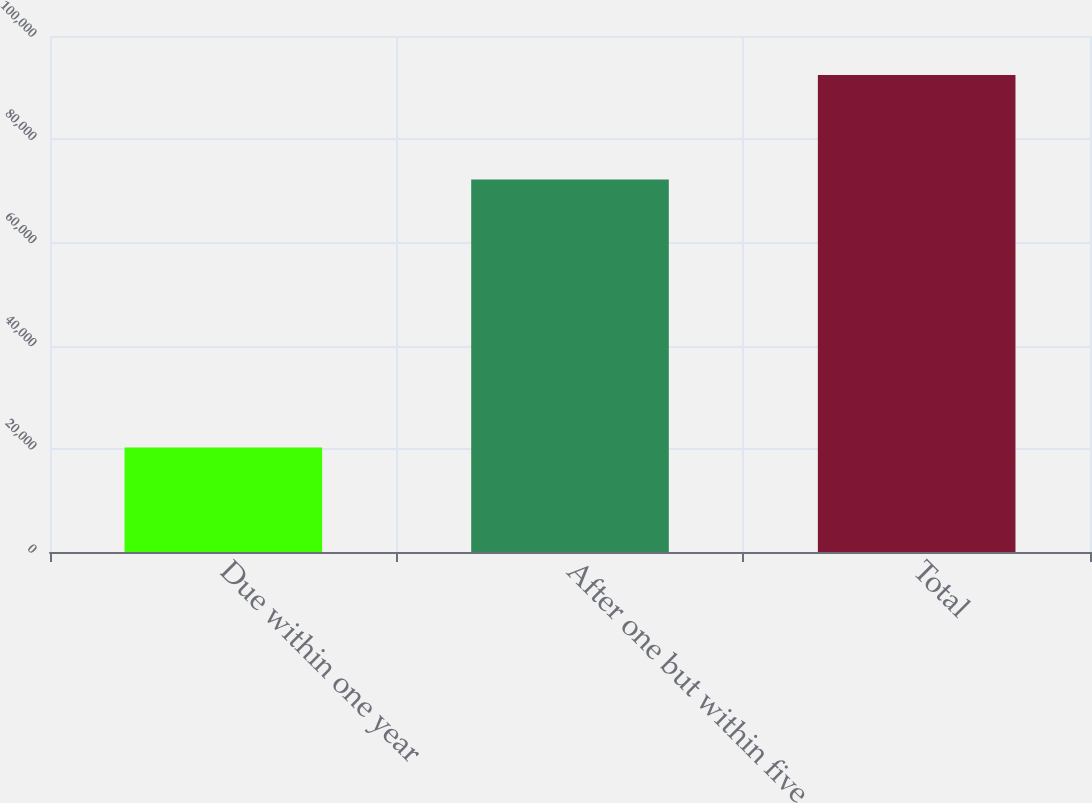Convert chart. <chart><loc_0><loc_0><loc_500><loc_500><bar_chart><fcel>Due within one year<fcel>After one but within five<fcel>Total<nl><fcel>20250<fcel>72168<fcel>92418<nl></chart> 